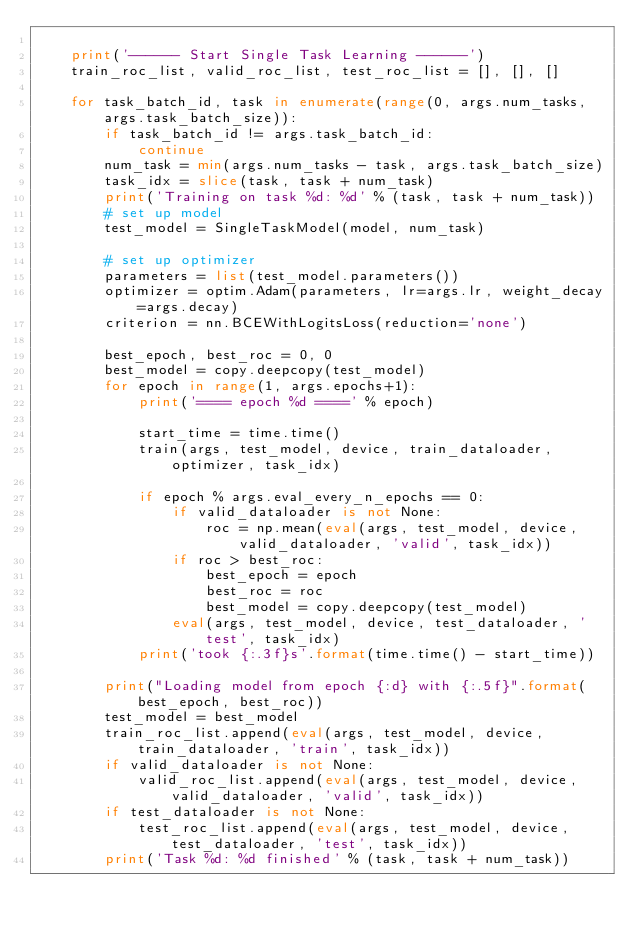Convert code to text. <code><loc_0><loc_0><loc_500><loc_500><_Python_>
    print('------ Start Single Task Learning ------')
    train_roc_list, valid_roc_list, test_roc_list = [], [], []

    for task_batch_id, task in enumerate(range(0, args.num_tasks, args.task_batch_size)):
        if task_batch_id != args.task_batch_id:
            continue
        num_task = min(args.num_tasks - task, args.task_batch_size)
        task_idx = slice(task, task + num_task)
        print('Training on task %d: %d' % (task, task + num_task))
        # set up model
        test_model = SingleTaskModel(model, num_task)

        # set up optimizer
        parameters = list(test_model.parameters())
        optimizer = optim.Adam(parameters, lr=args.lr, weight_decay=args.decay)
        criterion = nn.BCEWithLogitsLoss(reduction='none')

        best_epoch, best_roc = 0, 0
        best_model = copy.deepcopy(test_model)
        for epoch in range(1, args.epochs+1):
            print('==== epoch %d ====' % epoch)

            start_time = time.time()
            train(args, test_model, device, train_dataloader, optimizer, task_idx)

            if epoch % args.eval_every_n_epochs == 0:
                if valid_dataloader is not None:
                    roc = np.mean(eval(args, test_model, device, valid_dataloader, 'valid', task_idx))
                if roc > best_roc:
                    best_epoch = epoch
                    best_roc = roc
                    best_model = copy.deepcopy(test_model)
                eval(args, test_model, device, test_dataloader, 'test', task_idx)
            print('took {:.3f}s'.format(time.time() - start_time))

        print("Loading model from epoch {:d} with {:.5f}".format(best_epoch, best_roc))
        test_model = best_model
        train_roc_list.append(eval(args, test_model, device, train_dataloader, 'train', task_idx))
        if valid_dataloader is not None:
            valid_roc_list.append(eval(args, test_model, device, valid_dataloader, 'valid', task_idx))
        if test_dataloader is not None:
            test_roc_list.append(eval(args, test_model, device, test_dataloader, 'test', task_idx))
        print('Task %d: %d finished' % (task, task + num_task))
</code> 